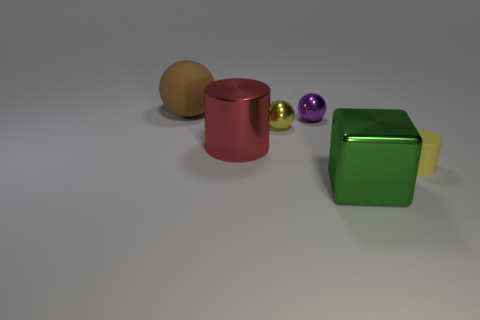There is a yellow metallic object; is its shape the same as the rubber thing that is in front of the brown rubber ball?
Your answer should be very brief. No. There is a thing that is behind the metallic block and in front of the big red thing; what is its size?
Your answer should be very brief. Small. Are there any other tiny things made of the same material as the tiny purple thing?
Make the answer very short. Yes. What is the size of the metallic thing that is the same color as the matte cylinder?
Ensure brevity in your answer.  Small. What material is the yellow thing that is in front of the cylinder behind the tiny yellow rubber cylinder made of?
Offer a very short reply. Rubber. How many other cylinders are the same color as the big cylinder?
Your answer should be compact. 0. There is a yellow cylinder that is made of the same material as the big brown ball; what size is it?
Your response must be concise. Small. What shape is the big thing that is to the right of the purple object?
Keep it short and to the point. Cube. What size is the metal object that is the same shape as the tiny yellow rubber thing?
Your response must be concise. Large. What number of big matte spheres are to the right of the cylinder that is behind the thing on the right side of the shiny block?
Your answer should be very brief. 0. 